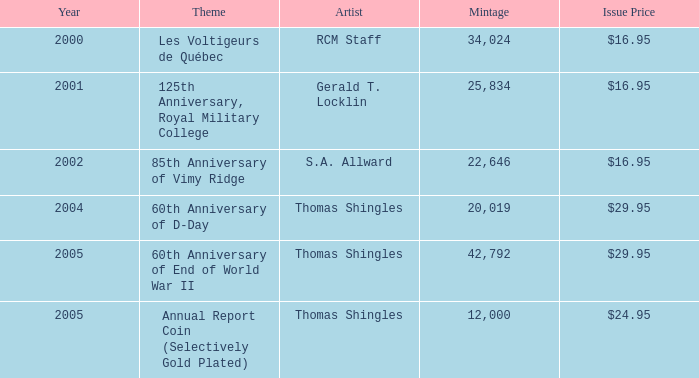95 launched? 2002.0. 